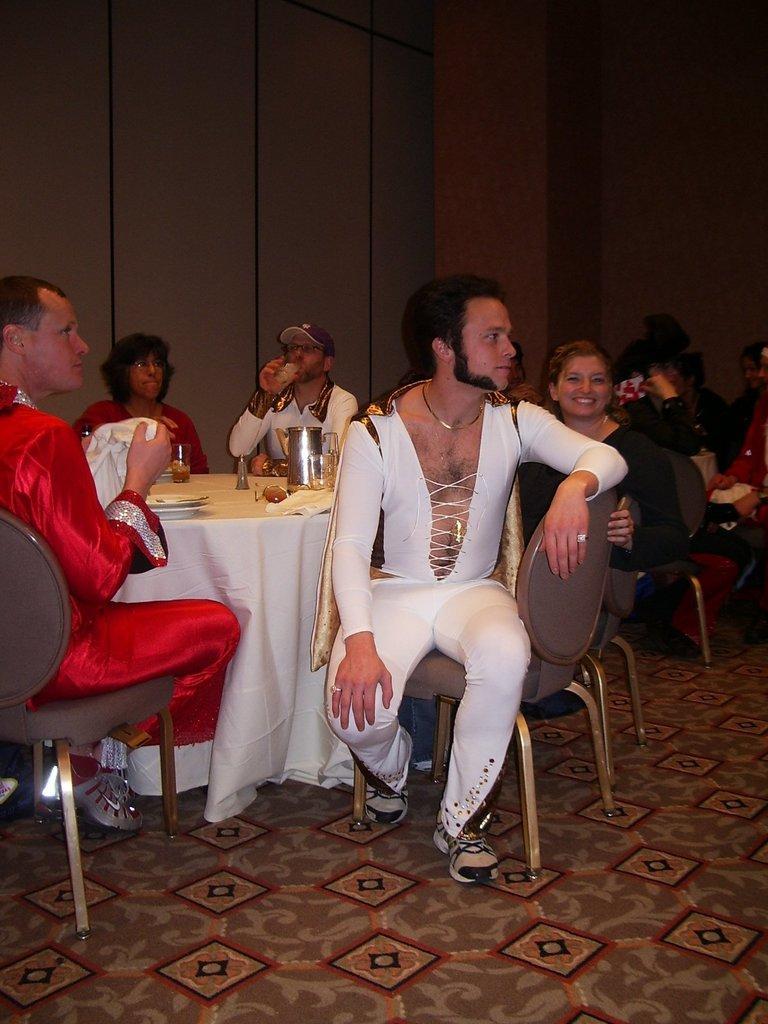Could you give a brief overview of what you see in this image? There are few people here sitting on the chair around the table. On the table we can see jar,food and glass on it. This is the wall. 